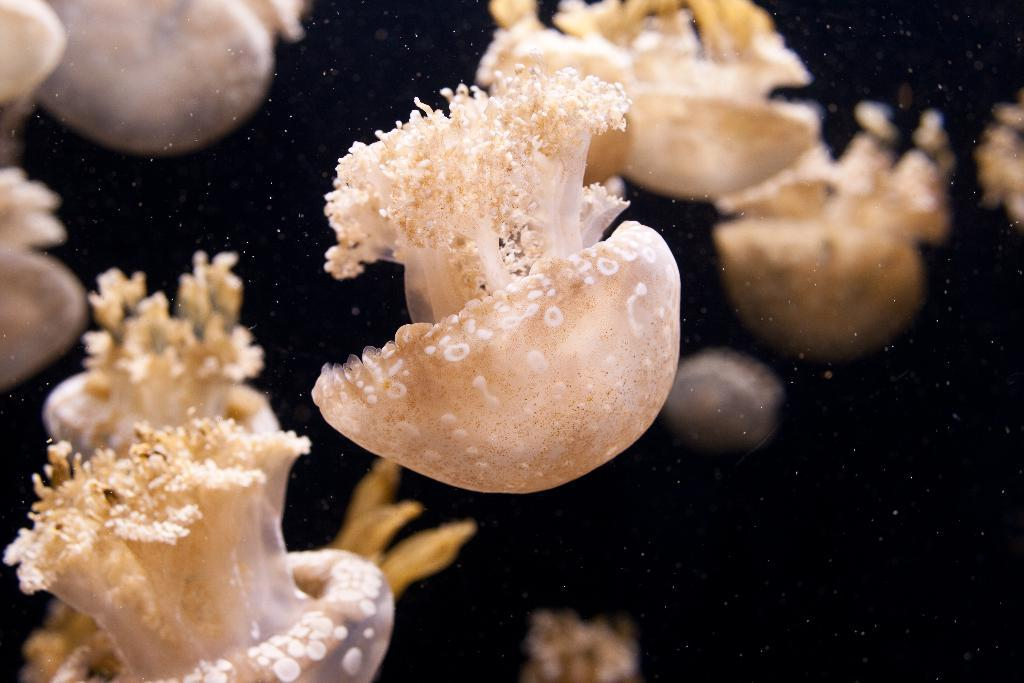What type of sea creatures are in the image? There are jellyfish in the image. What colors are the jellyfish? The jellyfish are in white and cream color. What color is the background of the image? The background of the image is black. What is your opinion on the scientific theory about the origin of jellyfish in the image? The image does not provide any information about the scientific theory or origin of the jellyfish, so it is not possible to answer this question based on the image alone. 